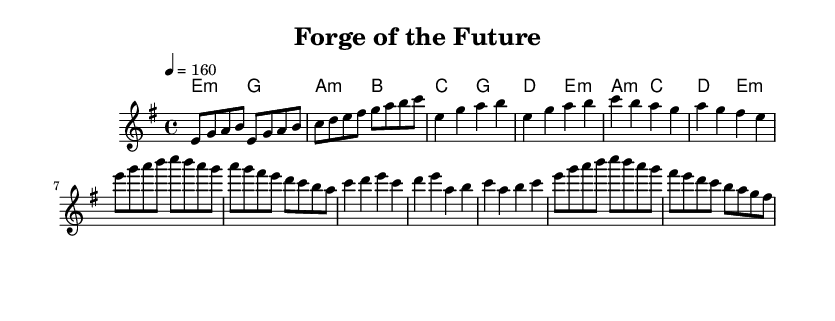What is the key signature of this music? The key signature is E minor, which has one sharp (F sharp). This can be determined by looking at the key signature marking at the beginning of the staff.
Answer: E minor What is the time signature of this music? The time signature is 4/4, indicating four beats per measure with a quarter note receiving one beat. This is typically represented at the beginning of the sheet music, right after the key signature.
Answer: 4/4 What is the tempo marking for this piece? The tempo marking is 4 equals 160, which indicates that there are 160 beats per minute. This information is located at the start of the music, providing guidance on the speed of the performance.
Answer: 160 How many measures are in the chorus section? The chorus section contains 8 measures. By analyzing the layout of the music, each measure can be counted from the start of the chorus to its end.
Answer: 8 What type of chords are used in the harmonies? The harmonies consist of minor chords and major chords, which are represented textually using "m" for minor and the absence of "m" for major. This reflects the overall tonal quality typical for power metal music.
Answer: Minor and major Which section immediately follows the verse in this music? The chorus immediately follows the verse, identifiable by the distinctive melodic shifts and changes in rhythm typically found between these two sections in many musical forms.
Answer: Chorus What is the primary theme or focus of the lyrics implied by the title of the piece? The title "Forge of the Future" suggests that the lyrics focus on themes related to innovation and sustainability, likely reflecting a narrative about clean energy pioneers. This is inferred from the title rather than the sheet music itself.
Answer: Clean energy 